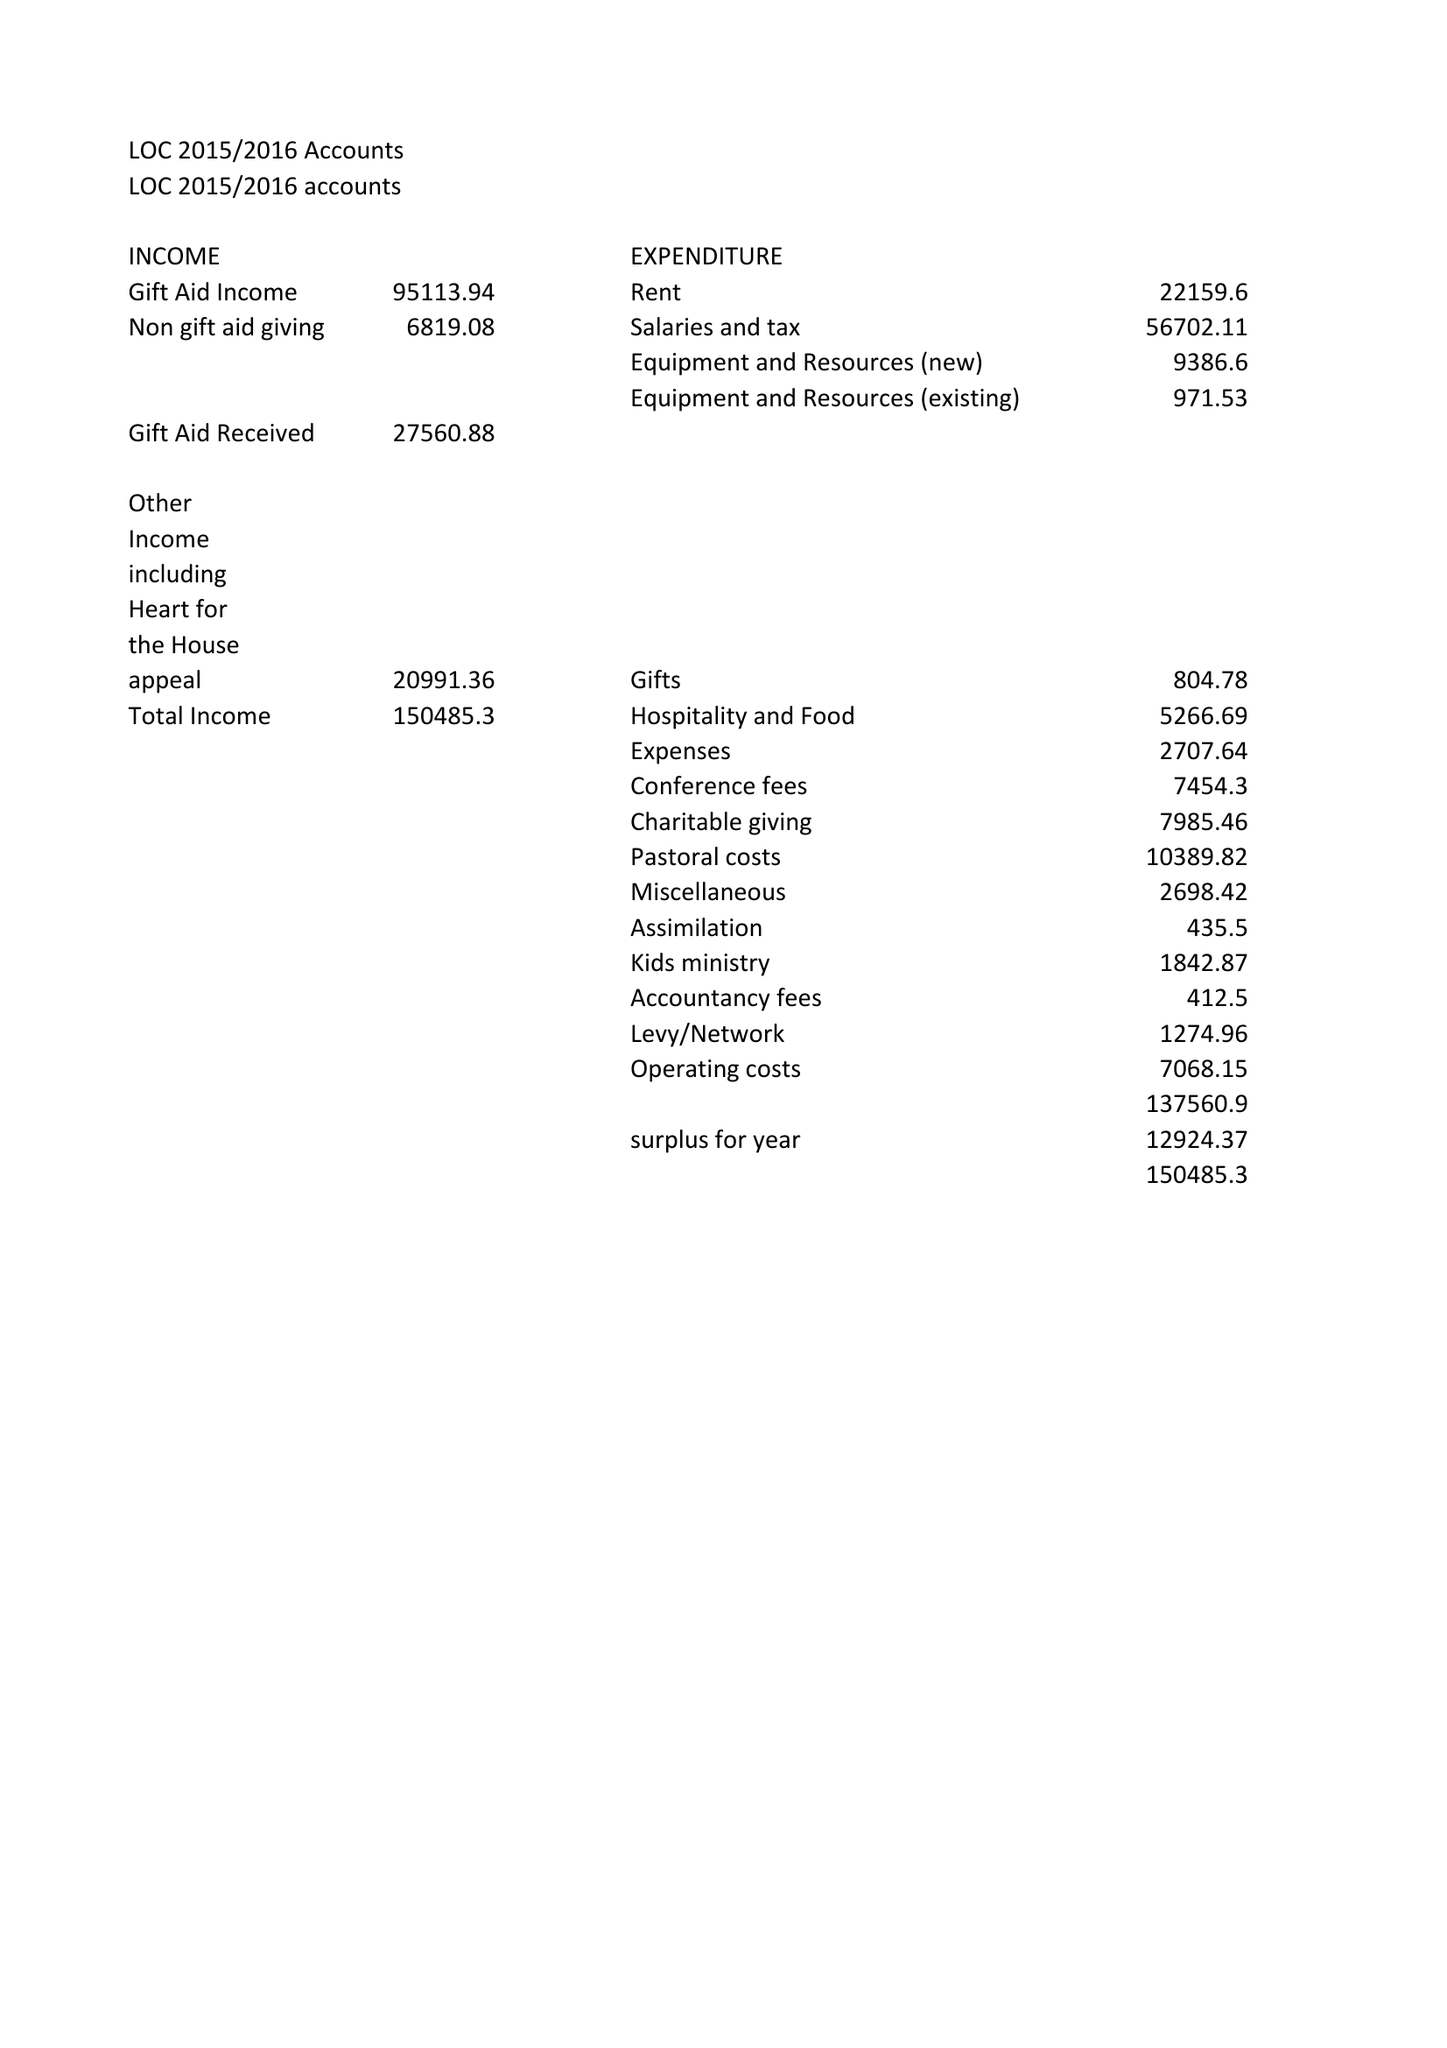What is the value for the spending_annually_in_british_pounds?
Answer the question using a single word or phrase. 137560.90 